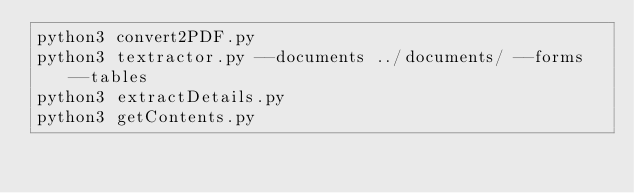<code> <loc_0><loc_0><loc_500><loc_500><_Bash_>python3 convert2PDF.py
python3 textractor.py --documents ../documents/ --forms --tables
python3 extractDetails.py
python3 getContents.py</code> 